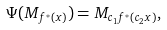<formula> <loc_0><loc_0><loc_500><loc_500>\Psi ( M _ { f ^ { * } ( x ) } ) = M _ { c _ { 1 } f ^ { * } ( c _ { 2 } x ) } ,</formula> 